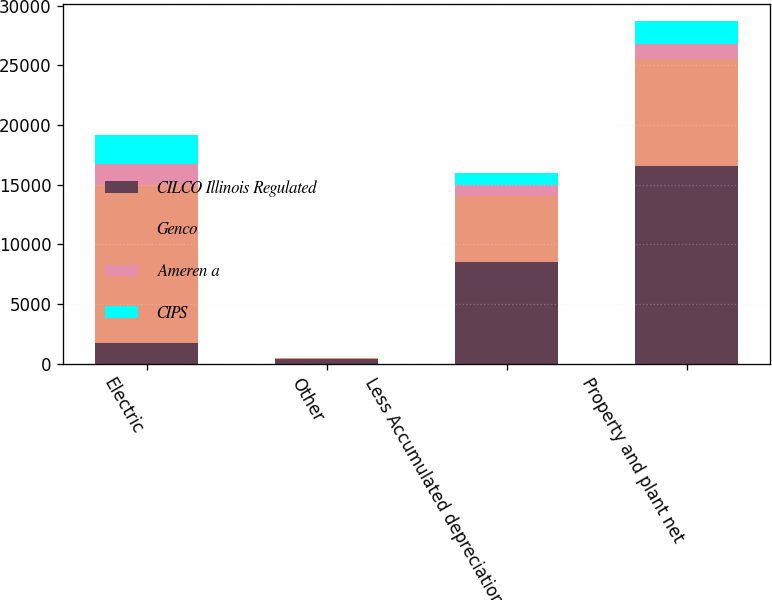<chart> <loc_0><loc_0><loc_500><loc_500><stacked_bar_chart><ecel><fcel>Electric<fcel>Other<fcel>Less Accumulated depreciation<fcel>Property and plant net<nl><fcel>CILCO Illinois Regulated<fcel>1744<fcel>381<fcel>8499<fcel>16567<nl><fcel>Genco<fcel>13214<fcel>76<fcel>5539<fcel>8995<nl><fcel>Ameren a<fcel>1744<fcel>6<fcel>915<fcel>1212<nl><fcel>CIPS<fcel>2451<fcel>6<fcel>1013<fcel>1950<nl></chart> 